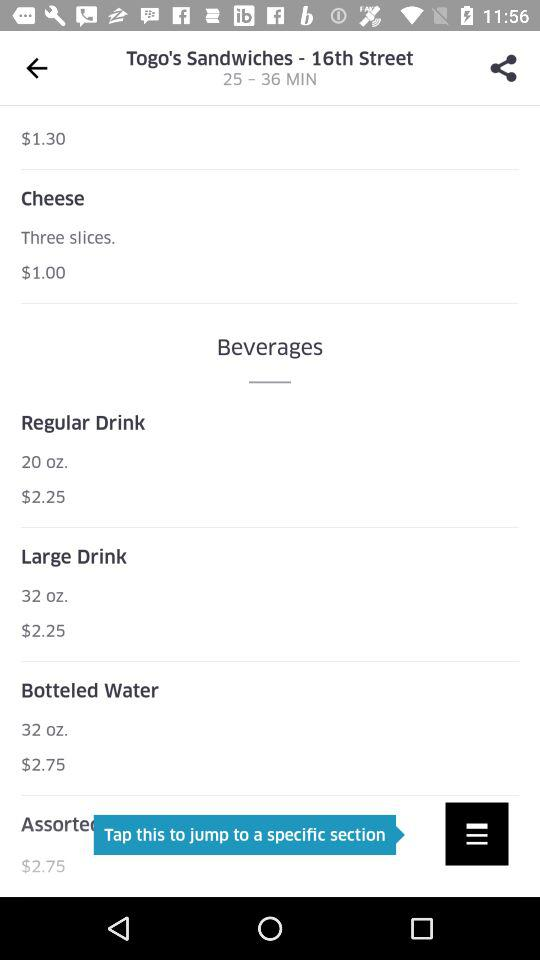What's the price of three slices of "Cheese"? The price of three slices of "Cheese" is $1. 